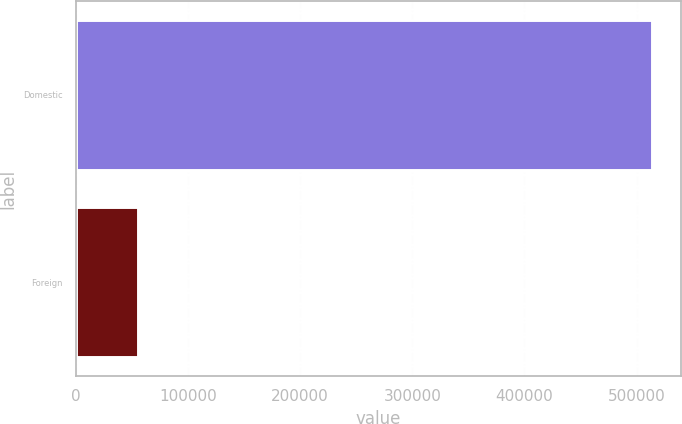Convert chart. <chart><loc_0><loc_0><loc_500><loc_500><bar_chart><fcel>Domestic<fcel>Foreign<nl><fcel>513746<fcel>55733<nl></chart> 